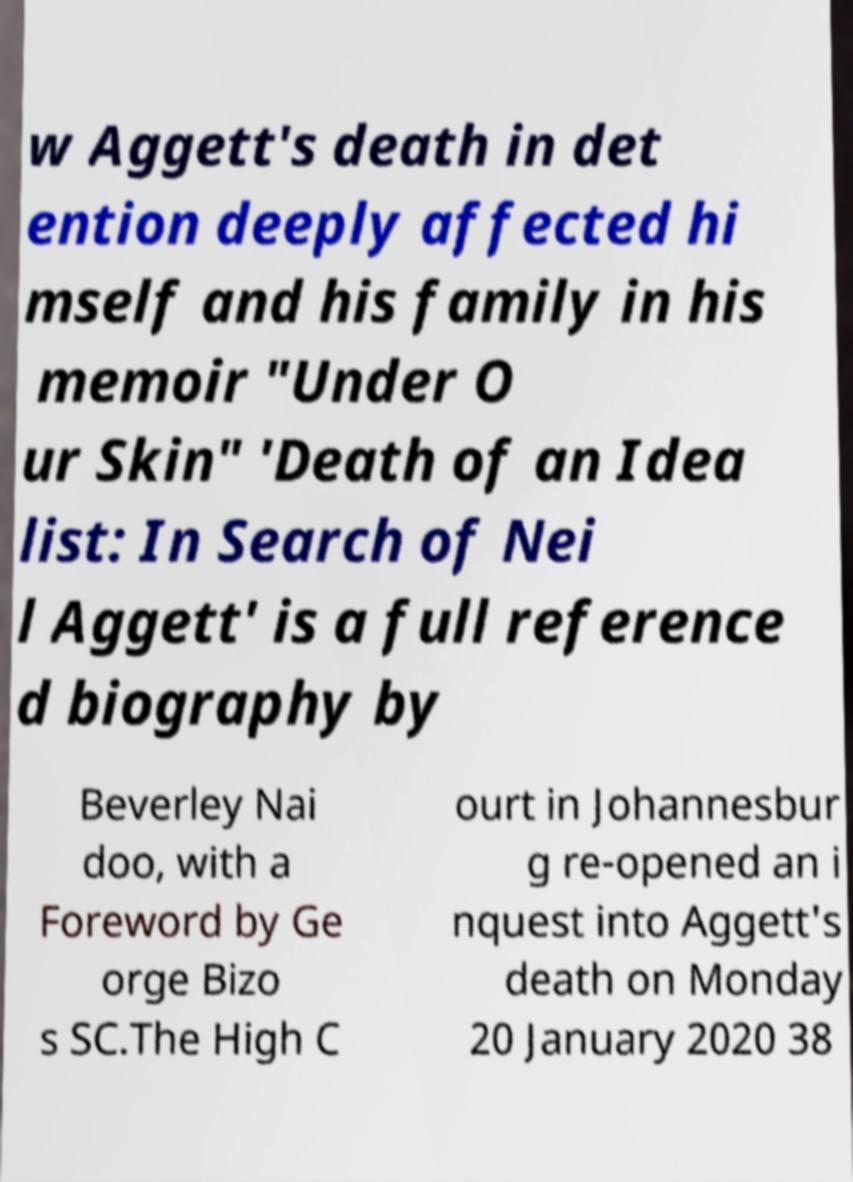I need the written content from this picture converted into text. Can you do that? w Aggett's death in det ention deeply affected hi mself and his family in his memoir "Under O ur Skin" 'Death of an Idea list: In Search of Nei l Aggett' is a full reference d biography by Beverley Nai doo, with a Foreword by Ge orge Bizo s SC.The High C ourt in Johannesbur g re-opened an i nquest into Aggett's death on Monday 20 January 2020 38 